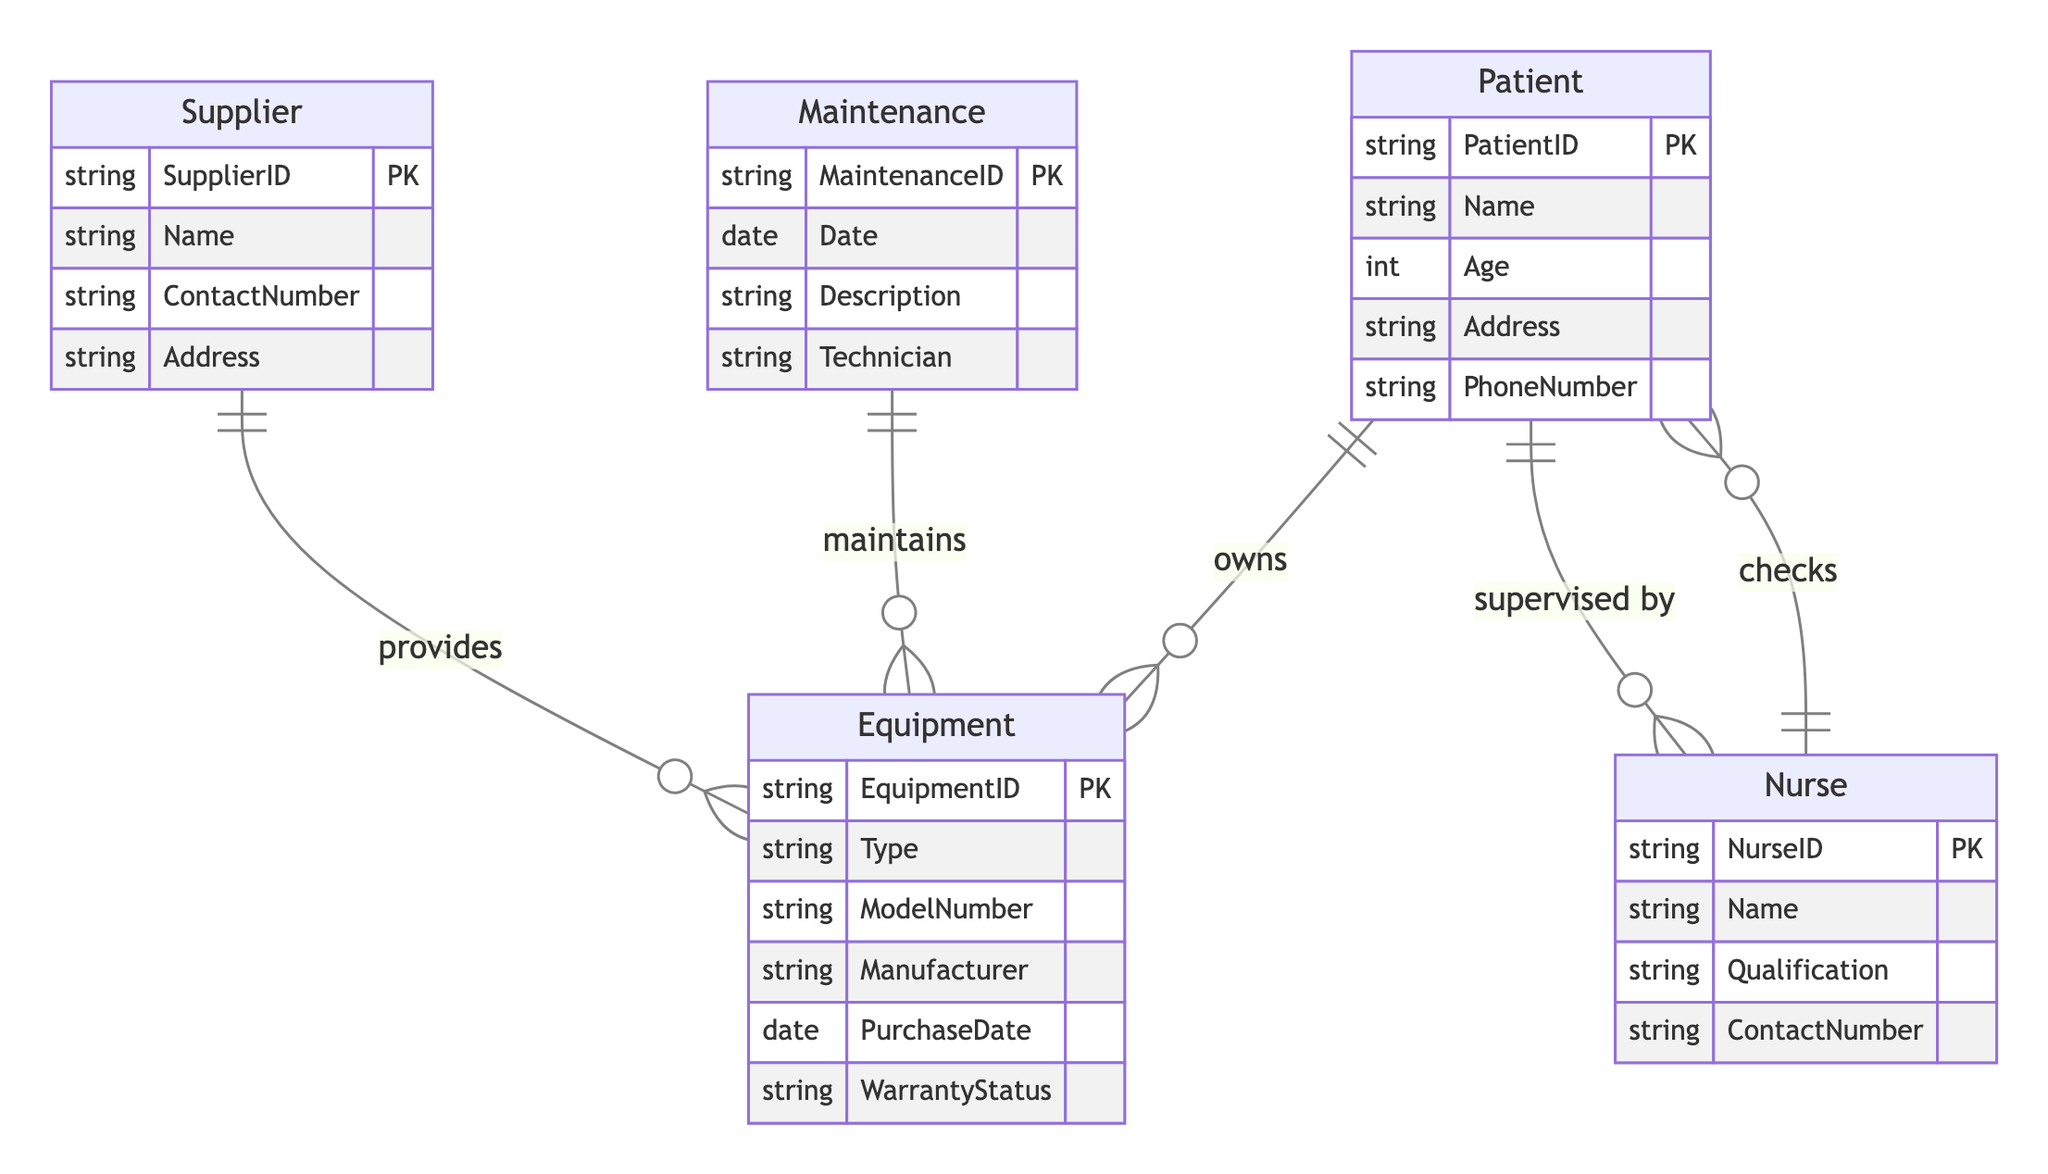What is the primary relationship between Patient and Equipment? The primary relationship between Patient and Equipment is represented by the "owns" relationship, indicating that a patient possesses specific medical equipment.
Answer: owns How many entities are present in the diagram? There are five entities present in the diagram: Patient, Equipment, Supplier, Nurse, and Maintenance.
Answer: five What type of attribute is 'Type' in the Equipment entity? The attribute 'Type' in the Equipment entity is a string, which means it represents textual information regarding the category of the equipment.
Answer: string Which entity provides Equipment? The Supplier entity provides Equipment, as indicated by the "provides" relationship flowing from Supplier to Equipment.
Answer: Supplier What relationship ties a Nurse to a Patient? There are two relationships that tie a Nurse to a Patient: "checks" and "supervised by," indicating the Nurse's duties in monitoring and overseeing the Patient's care.
Answer: checks, supervised by Which entity is responsible for maintaining Equipment? The Maintenance entity is responsible for maintaining Equipment, as shown by the "maintains" relationship from Maintenance to Equipment.
Answer: Maintenance If a Patient owns multiple Equipment types, what relationship describes that? The relationship "owns" describes that multiple Equipment types can be owned by a single Patient, showcasing a one-to-many relationship.
Answer: owns What is the function of the Maintenance entity within this system? The Maintenance entity serves to record details about the maintenance events related to Equipment, which includes attributes like Date, Description, and Technician.
Answer: records maintenance details How do Nurses interact with Patients according to the diagram? Nurses interact with Patients primarily through the relationships of "checks" and "supervised by," indicating they are responsible for regular health check-ups and overseeing care.
Answer: checks, supervised by 